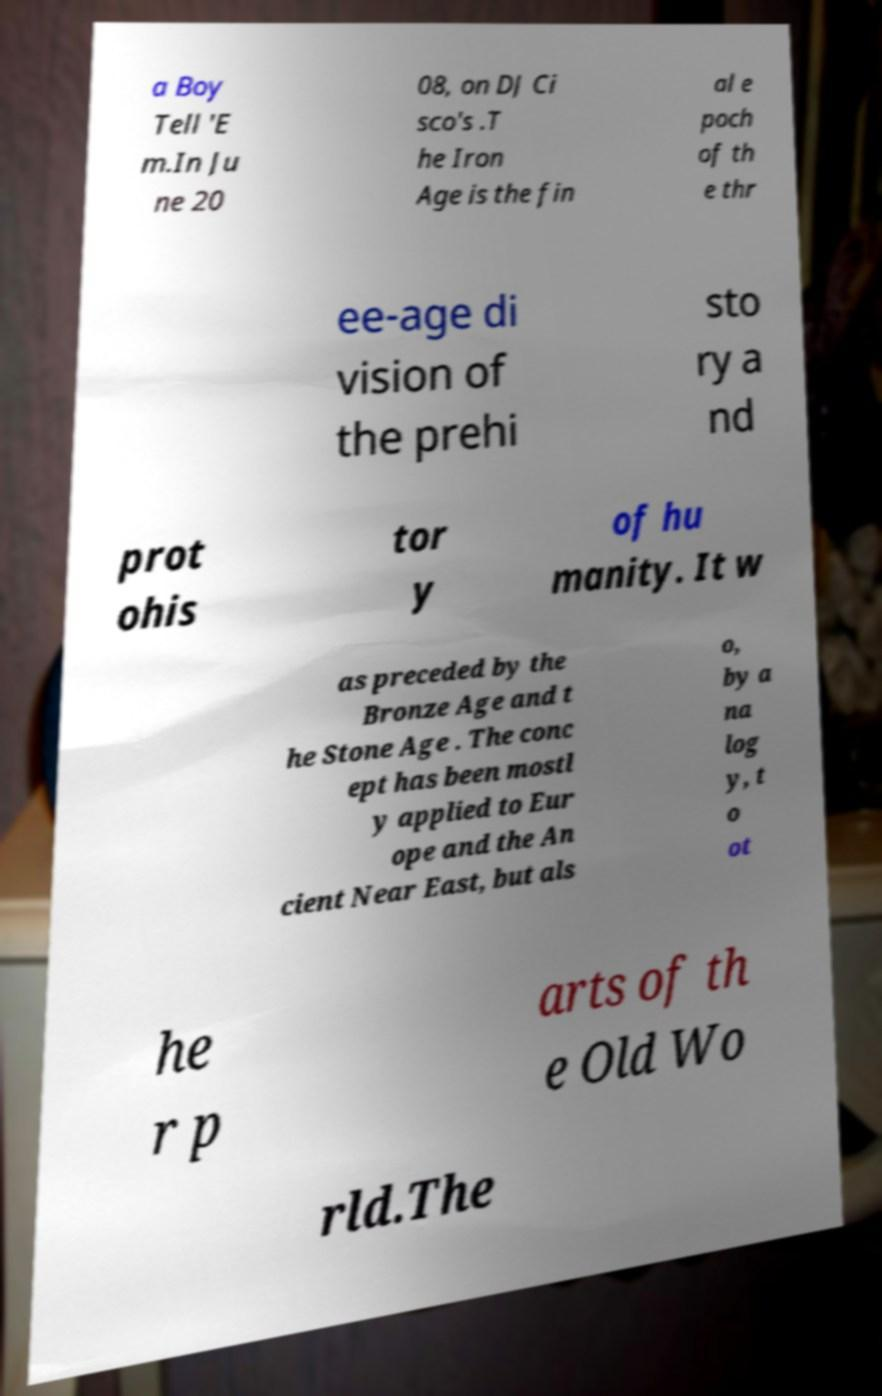Could you extract and type out the text from this image? a Boy Tell 'E m.In Ju ne 20 08, on DJ Ci sco's .T he Iron Age is the fin al e poch of th e thr ee-age di vision of the prehi sto ry a nd prot ohis tor y of hu manity. It w as preceded by the Bronze Age and t he Stone Age . The conc ept has been mostl y applied to Eur ope and the An cient Near East, but als o, by a na log y, t o ot he r p arts of th e Old Wo rld.The 